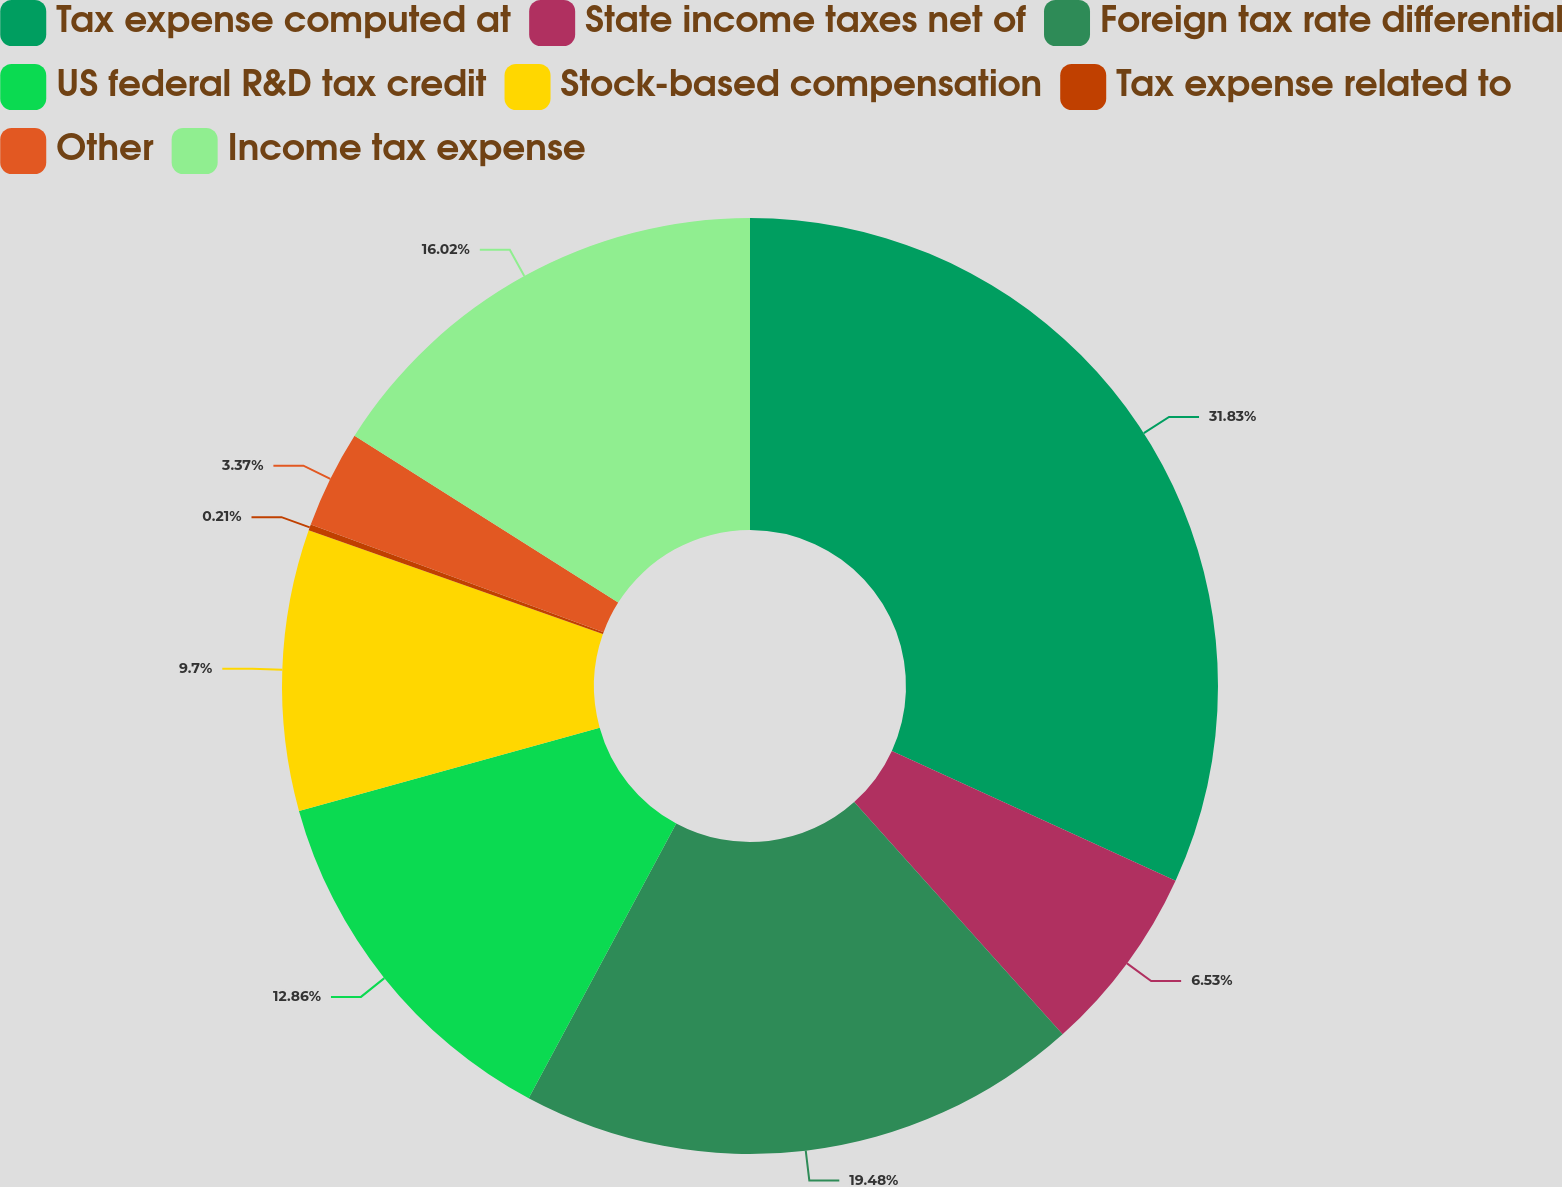<chart> <loc_0><loc_0><loc_500><loc_500><pie_chart><fcel>Tax expense computed at<fcel>State income taxes net of<fcel>Foreign tax rate differential<fcel>US federal R&D tax credit<fcel>Stock-based compensation<fcel>Tax expense related to<fcel>Other<fcel>Income tax expense<nl><fcel>31.83%<fcel>6.53%<fcel>19.48%<fcel>12.86%<fcel>9.7%<fcel>0.21%<fcel>3.37%<fcel>16.02%<nl></chart> 